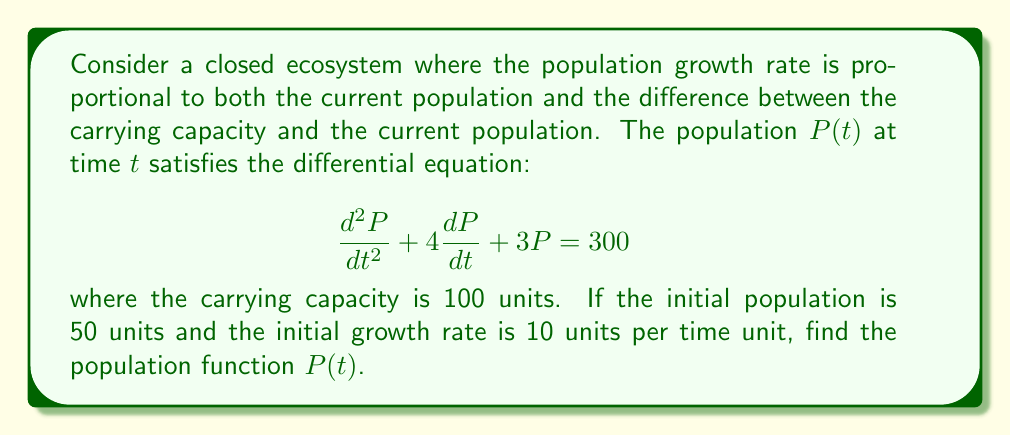Can you solve this math problem? Let's approach this step-by-step:

1) First, we need to identify the type of equation. This is a non-homogeneous second-order linear differential equation with constant coefficients.

2) The general solution will be the sum of the complementary function (solution to the homogeneous equation) and a particular solution.

3) For the complementary function, we solve the characteristic equation:
   $$r^2 + 4r + 3 = 0$$
   $$(r + 1)(r + 3) = 0$$
   $$r = -1 \text{ or } r = -3$$

   So the complementary function is:
   $$P_c(t) = c_1e^{-t} + c_2e^{-3t}$$

4) For the particular solution, since the right-hand side is a constant, we guess a constant solution:
   $$P_p(t) = A$$
   
   Substituting this into the original equation:
   $$0 + 0 + 3A = 300$$
   $$A = 100$$

5) The general solution is:
   $$P(t) = c_1e^{-t} + c_2e^{-3t} + 100$$

6) Now we use the initial conditions to find $c_1$ and $c_2$:
   
   At $t = 0$, $P(0) = 50$:
   $$50 = c_1 + c_2 + 100$$
   $$c_1 + c_2 = -50 \quad (1)$$

   For the initial growth rate, we differentiate $P(t)$:
   $$\frac{dP}{dt} = -c_1e^{-t} - 3c_2e^{-3t}$$
   
   At $t = 0$, $\frac{dP}{dt}(0) = 10$:
   $$10 = -c_1 - 3c_2 \quad (2)$$

7) Solving equations (1) and (2):
   $$c_1 = -40, c_2 = -10$$

Therefore, the population function is:
$$P(t) = -40e^{-t} - 10e^{-3t} + 100$$
Answer: $$P(t) = -40e^{-t} - 10e^{-3t} + 100$$ 